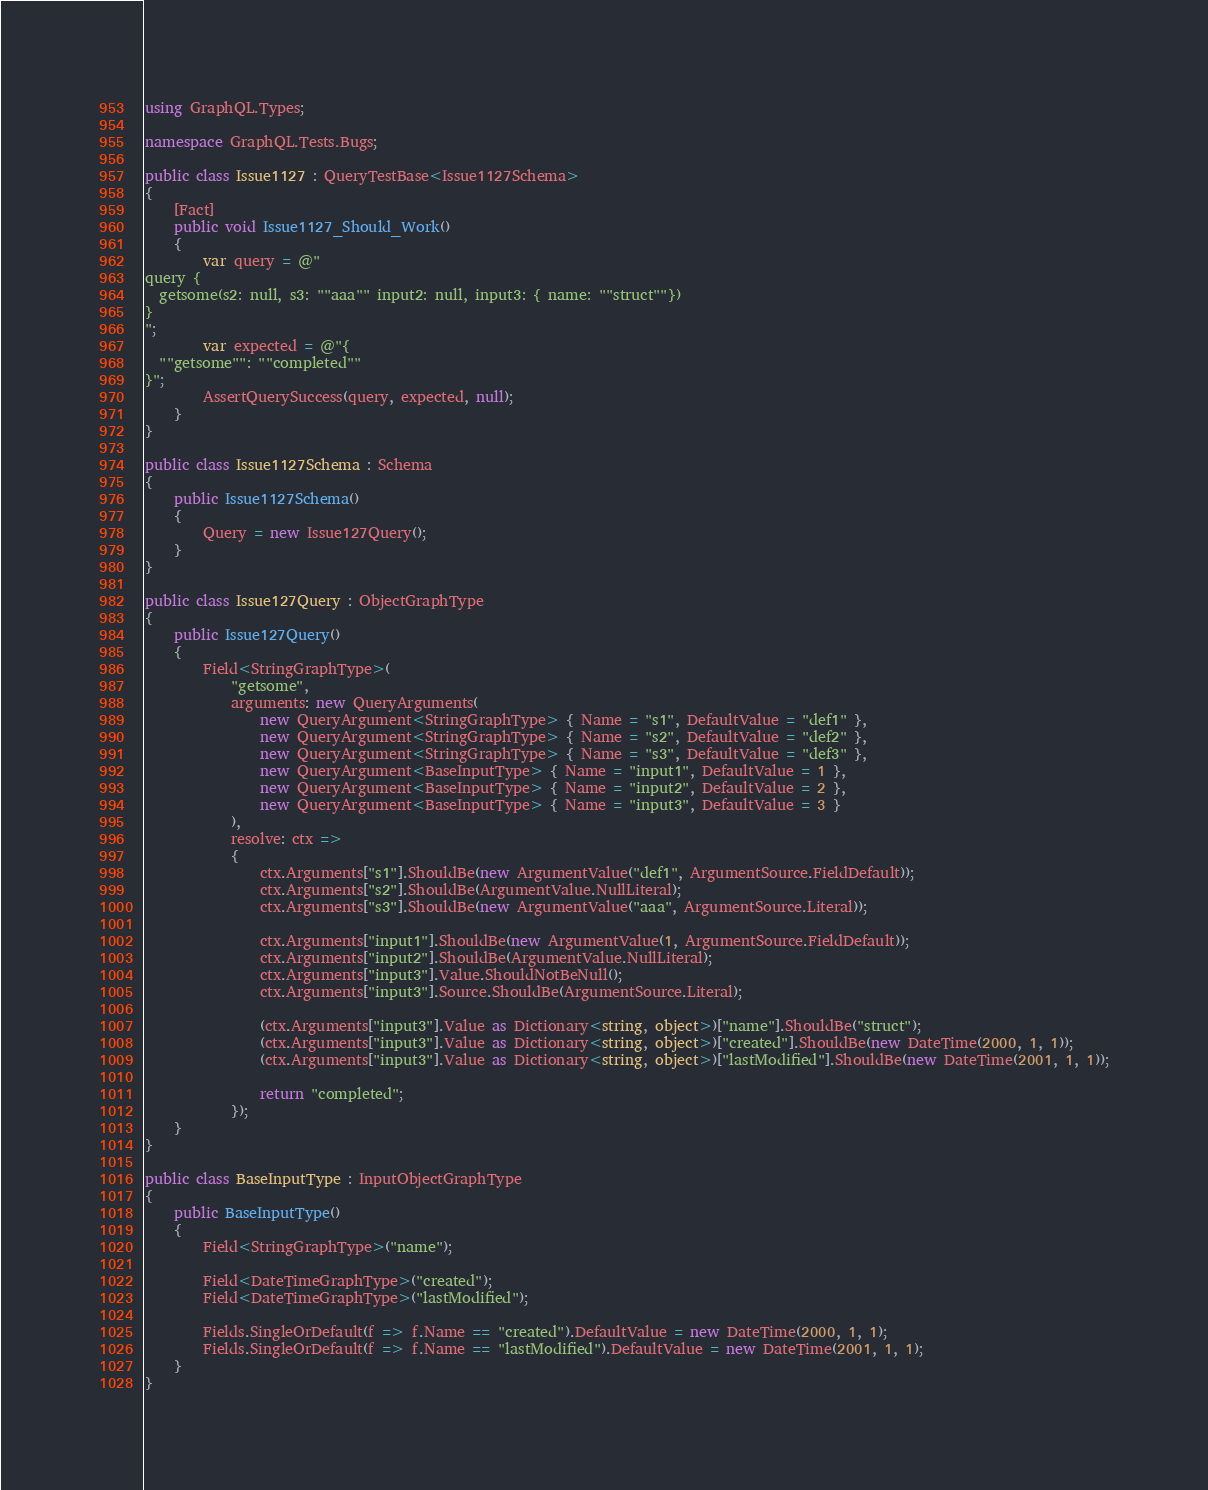Convert code to text. <code><loc_0><loc_0><loc_500><loc_500><_C#_>using GraphQL.Types;

namespace GraphQL.Tests.Bugs;

public class Issue1127 : QueryTestBase<Issue1127Schema>
{
    [Fact]
    public void Issue1127_Should_Work()
    {
        var query = @"
query {
  getsome(s2: null, s3: ""aaa"" input2: null, input3: { name: ""struct""})
}
";
        var expected = @"{
  ""getsome"": ""completed""
}";
        AssertQuerySuccess(query, expected, null);
    }
}

public class Issue1127Schema : Schema
{
    public Issue1127Schema()
    {
        Query = new Issue127Query();
    }
}

public class Issue127Query : ObjectGraphType
{
    public Issue127Query()
    {
        Field<StringGraphType>(
            "getsome",
            arguments: new QueryArguments(
                new QueryArgument<StringGraphType> { Name = "s1", DefaultValue = "def1" },
                new QueryArgument<StringGraphType> { Name = "s2", DefaultValue = "def2" },
                new QueryArgument<StringGraphType> { Name = "s3", DefaultValue = "def3" },
                new QueryArgument<BaseInputType> { Name = "input1", DefaultValue = 1 },
                new QueryArgument<BaseInputType> { Name = "input2", DefaultValue = 2 },
                new QueryArgument<BaseInputType> { Name = "input3", DefaultValue = 3 }
            ),
            resolve: ctx =>
            {
                ctx.Arguments["s1"].ShouldBe(new ArgumentValue("def1", ArgumentSource.FieldDefault));
                ctx.Arguments["s2"].ShouldBe(ArgumentValue.NullLiteral);
                ctx.Arguments["s3"].ShouldBe(new ArgumentValue("aaa", ArgumentSource.Literal));

                ctx.Arguments["input1"].ShouldBe(new ArgumentValue(1, ArgumentSource.FieldDefault));
                ctx.Arguments["input2"].ShouldBe(ArgumentValue.NullLiteral);
                ctx.Arguments["input3"].Value.ShouldNotBeNull();
                ctx.Arguments["input3"].Source.ShouldBe(ArgumentSource.Literal);

                (ctx.Arguments["input3"].Value as Dictionary<string, object>)["name"].ShouldBe("struct");
                (ctx.Arguments["input3"].Value as Dictionary<string, object>)["created"].ShouldBe(new DateTime(2000, 1, 1));
                (ctx.Arguments["input3"].Value as Dictionary<string, object>)["lastModified"].ShouldBe(new DateTime(2001, 1, 1));

                return "completed";
            });
    }
}

public class BaseInputType : InputObjectGraphType
{
    public BaseInputType()
    {
        Field<StringGraphType>("name");

        Field<DateTimeGraphType>("created");
        Field<DateTimeGraphType>("lastModified");

        Fields.SingleOrDefault(f => f.Name == "created").DefaultValue = new DateTime(2000, 1, 1);
        Fields.SingleOrDefault(f => f.Name == "lastModified").DefaultValue = new DateTime(2001, 1, 1);
    }
}
</code> 